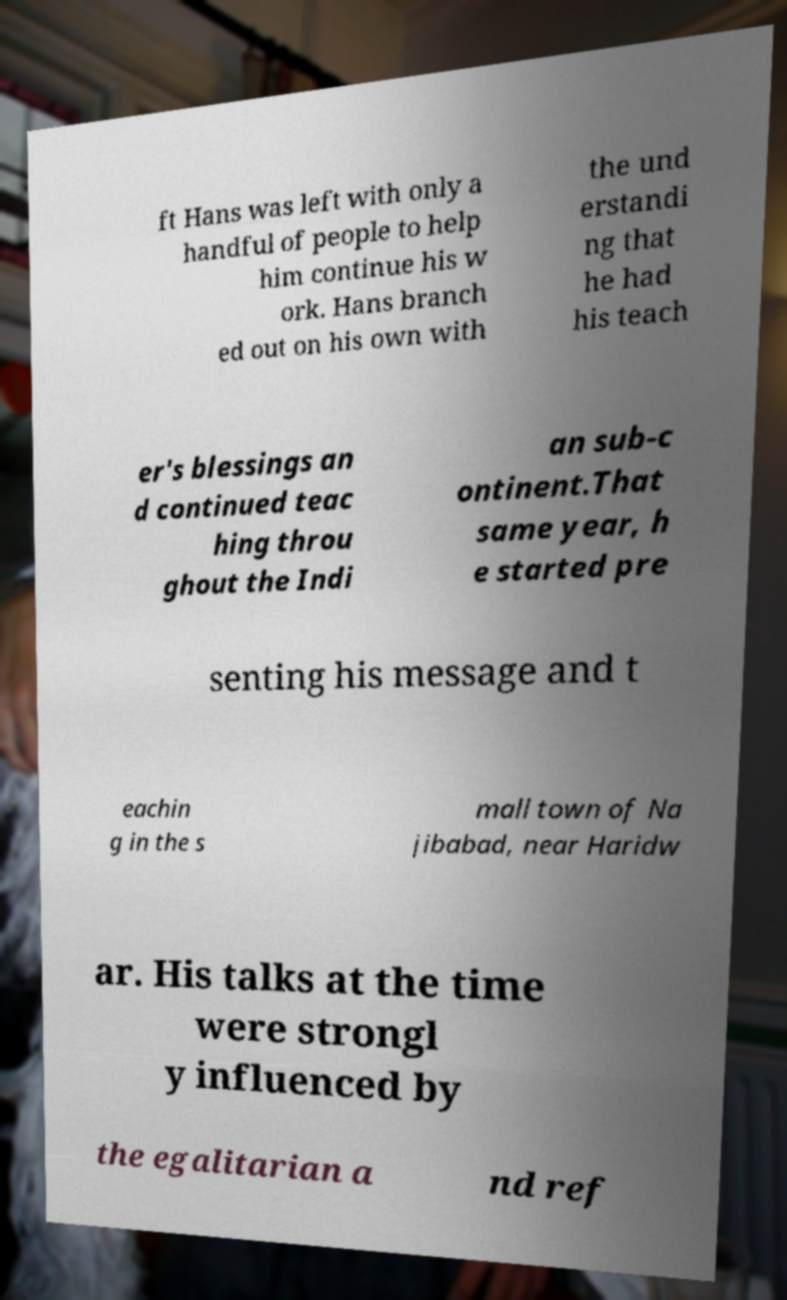I need the written content from this picture converted into text. Can you do that? ft Hans was left with only a handful of people to help him continue his w ork. Hans branch ed out on his own with the und erstandi ng that he had his teach er's blessings an d continued teac hing throu ghout the Indi an sub-c ontinent.That same year, h e started pre senting his message and t eachin g in the s mall town of Na jibabad, near Haridw ar. His talks at the time were strongl y influenced by the egalitarian a nd ref 